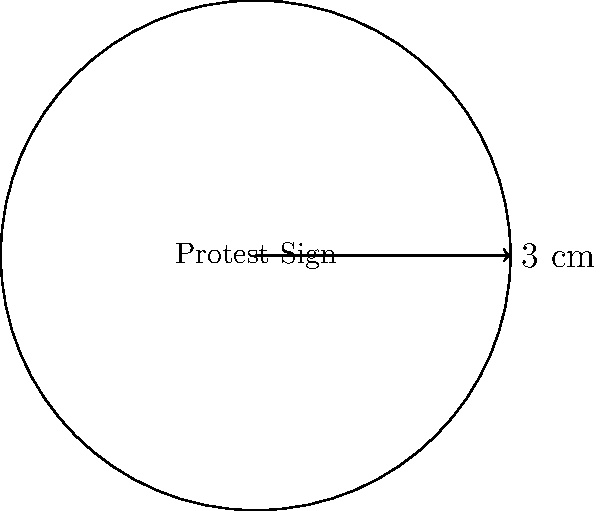As an activist, you want to create a circular protest sign. If the radius of the sign is 3 cm, what is the area of the sign in square centimeters? (Use $\pi \approx 3.14$) To calculate the area of a circular protest sign, we need to use the formula for the area of a circle:

1. The formula for the area of a circle is $A = \pi r^2$, where $A$ is the area and $r$ is the radius.

2. We are given that the radius is 3 cm and $\pi \approx 3.14$.

3. Let's substitute these values into the formula:
   $A = \pi r^2$
   $A = 3.14 \times 3^2$

4. Calculate the square of the radius:
   $A = 3.14 \times 9$

5. Multiply:
   $A = 28.26$ cm²

Therefore, the area of the circular protest sign is approximately 28.26 square centimeters.
Answer: $28.26$ cm² 